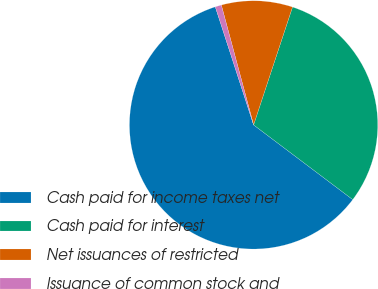<chart> <loc_0><loc_0><loc_500><loc_500><pie_chart><fcel>Cash paid for income taxes net<fcel>Cash paid for interest<fcel>Net issuances of restricted<fcel>Issuance of common stock and<nl><fcel>59.73%<fcel>30.2%<fcel>9.26%<fcel>0.81%<nl></chart> 